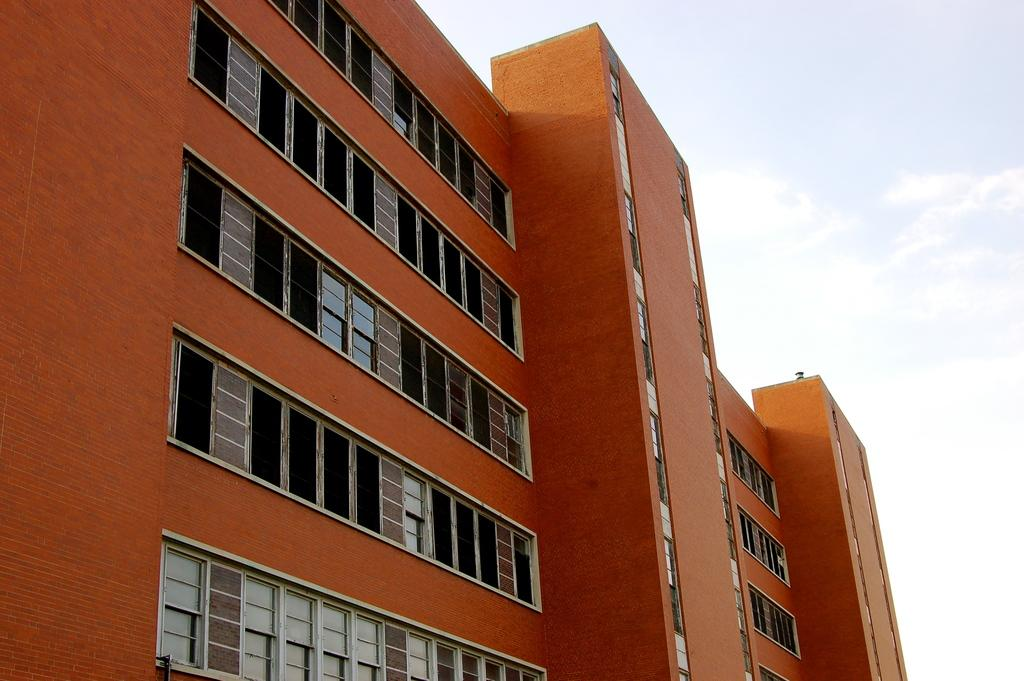What is the main subject of the picture? The main subject of the picture is a building. What specific features can be seen on the building? The building has windows. What is visible in the background of the picture? The sky is visible in the picture. Can you describe the sky in the picture? There are clouds in the sky. What type of silver can be seen shining in the picture? There is no silver present in the image; it features a building with windows and a cloudy sky. Can you describe the shade of the tooth in the picture? There is no tooth present in the image. 